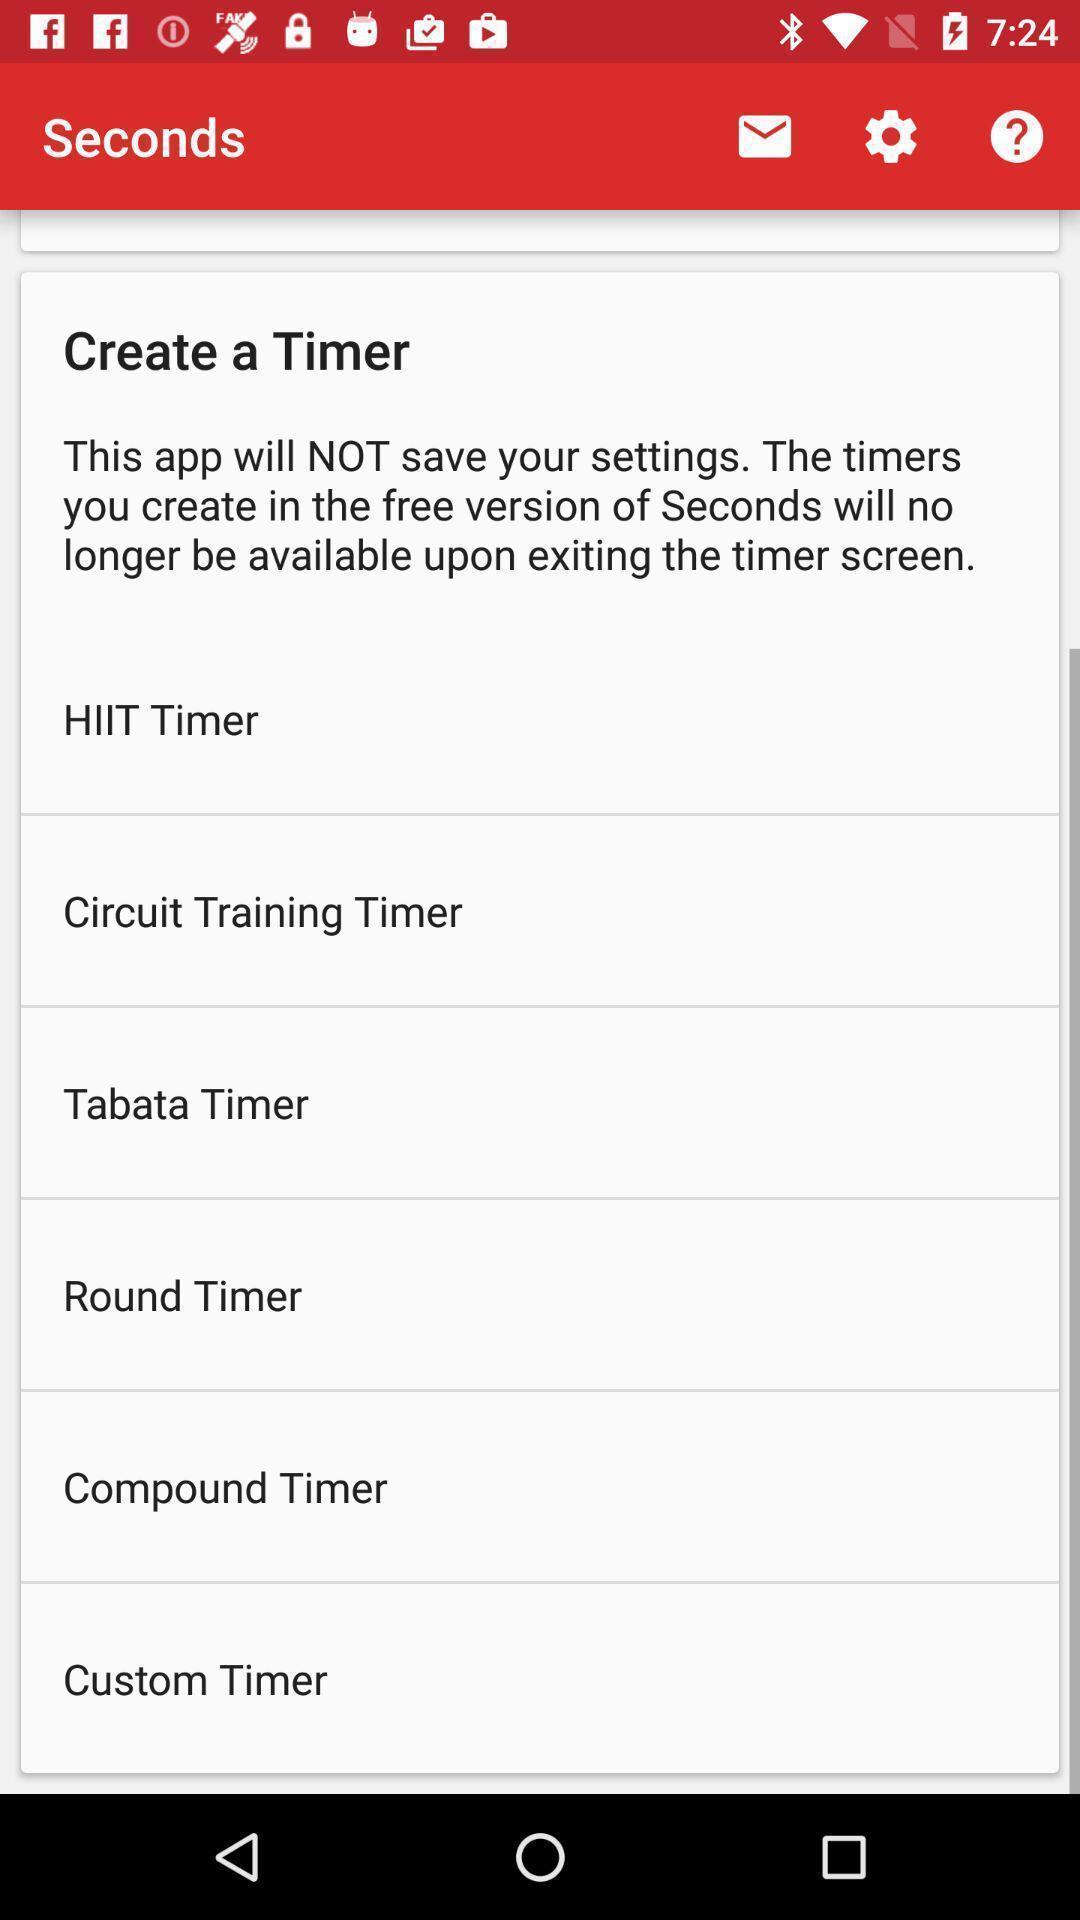Tell me about the visual elements in this screen capture. Screen displaying the page to create a timer. 